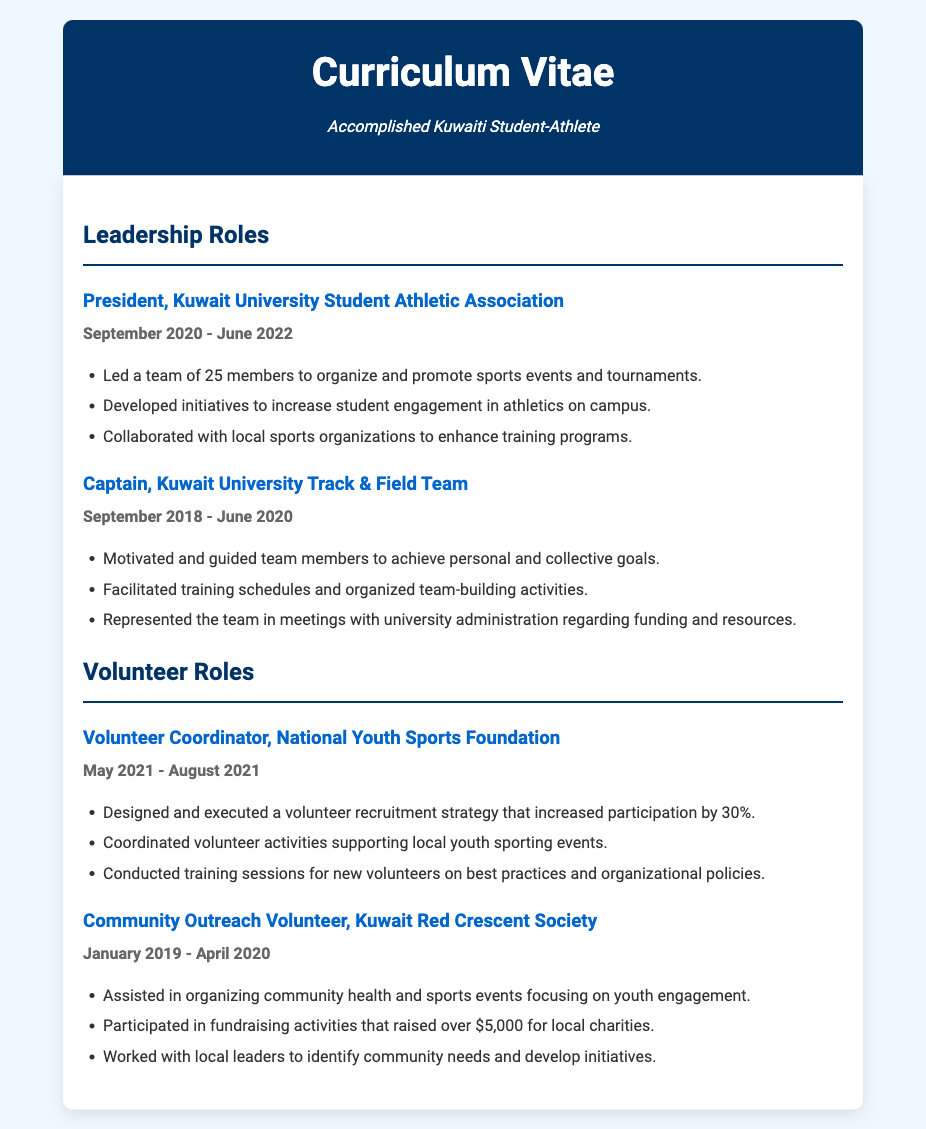What is the title of the leadership role held at Kuwait University Student Athletic Association? The title is listed under the Leadership Roles section of the document.
Answer: President, Kuwait University Student Athletic Association During which months and year did the Volunteer Coordinator role take place? The specific duration is mentioned under the Volunteer Roles section.
Answer: May 2021 - August 2021 How many members were led by the President of the Kuwait University Student Athletic Association? The number of members is mentioned in the responsibilities section under that leadership role.
Answer: 25 members Which organization did the Community Outreach Volunteer work with? The organization is specified at the beginning of the relevant role in the document.
Answer: Kuwait Red Crescent Society What was one of the achievements of the Volunteer Coordinator role? Achievements are listed in bullet points under each role, indicating significant contributions.
Answer: Increased participation by 30% What years did the Captain of the Kuwait University Track & Field Team serve? The duration is provided under the leadership role section in the document.
Answer: September 2018 - June 2020 What type of events did the Community Outreach Volunteer assist in organizing? The type of events is described in a bullet point under the volunteer role.
Answer: Community health and sports events What was a key responsibility of the Kuwait University Track & Field Team Captain? The responsibilities are detailed in the bullet points under the respective leadership role.
Answer: Represented the team in meetings with university administration 